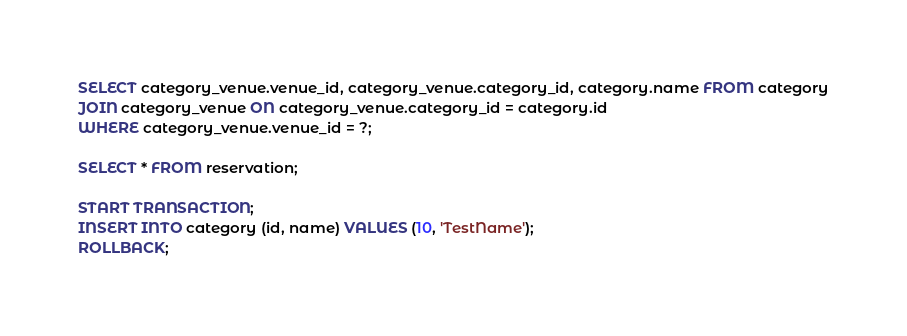<code> <loc_0><loc_0><loc_500><loc_500><_SQL_>SELECT category_venue.venue_id, category_venue.category_id, category.name FROM category
JOIN category_venue ON category_venue.category_id = category.id
WHERE category_venue.venue_id = ?;

SELECT * FROM reservation;

START TRANSACTION;
INSERT INTO category (id, name) VALUES (10, 'TestName');
ROLLBACK;
</code> 